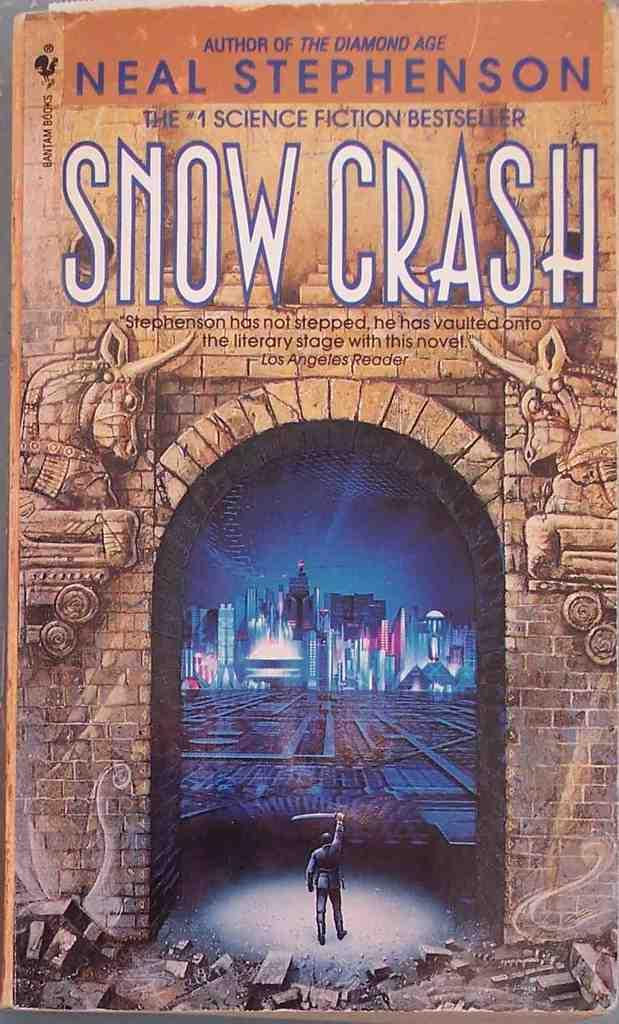<image>
Relay a brief, clear account of the picture shown. The front cover of a book by author, Neal Stephenson. 